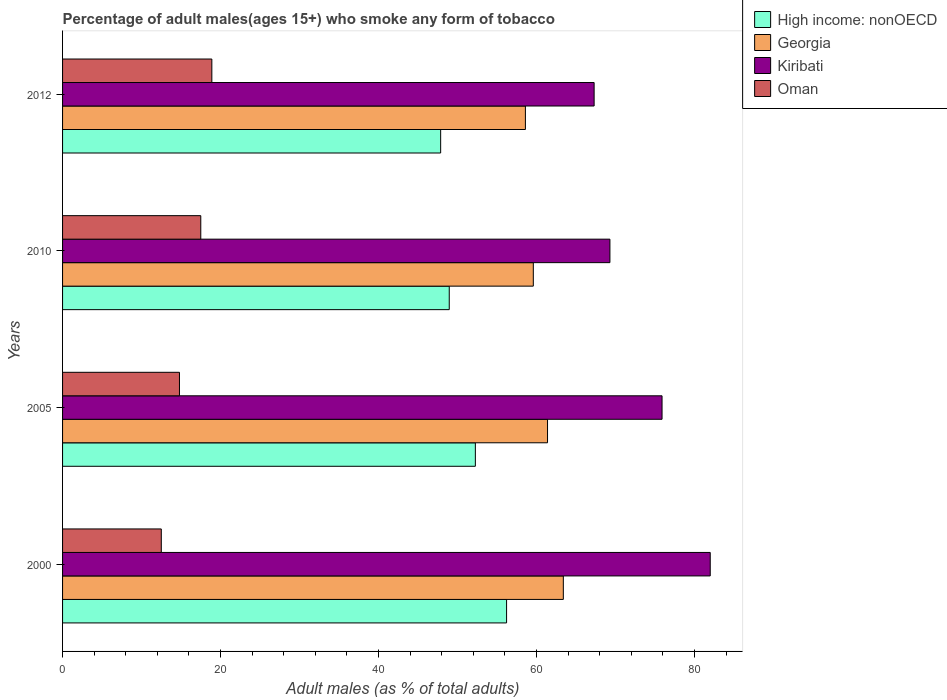How many different coloured bars are there?
Offer a very short reply. 4. How many groups of bars are there?
Keep it short and to the point. 4. Are the number of bars per tick equal to the number of legend labels?
Give a very brief answer. Yes. How many bars are there on the 3rd tick from the top?
Offer a very short reply. 4. What is the label of the 4th group of bars from the top?
Offer a very short reply. 2000. In how many cases, is the number of bars for a given year not equal to the number of legend labels?
Provide a succinct answer. 0. What is the percentage of adult males who smoke in Georgia in 2000?
Provide a short and direct response. 63.4. Across all years, what is the minimum percentage of adult males who smoke in Kiribati?
Keep it short and to the point. 67.3. In which year was the percentage of adult males who smoke in Kiribati maximum?
Give a very brief answer. 2000. In which year was the percentage of adult males who smoke in Oman minimum?
Offer a terse response. 2000. What is the total percentage of adult males who smoke in Kiribati in the graph?
Provide a succinct answer. 294.5. What is the difference between the percentage of adult males who smoke in High income: nonOECD in 2000 and that in 2012?
Keep it short and to the point. 8.35. What is the difference between the percentage of adult males who smoke in Oman in 2005 and the percentage of adult males who smoke in High income: nonOECD in 2000?
Keep it short and to the point. -41.42. What is the average percentage of adult males who smoke in High income: nonOECD per year?
Provide a short and direct response. 51.33. In the year 2012, what is the difference between the percentage of adult males who smoke in Oman and percentage of adult males who smoke in High income: nonOECD?
Provide a short and direct response. -28.97. In how many years, is the percentage of adult males who smoke in Georgia greater than 20 %?
Provide a short and direct response. 4. What is the ratio of the percentage of adult males who smoke in High income: nonOECD in 2000 to that in 2005?
Offer a very short reply. 1.08. Is the percentage of adult males who smoke in Georgia in 2000 less than that in 2010?
Ensure brevity in your answer.  No. Is the difference between the percentage of adult males who smoke in Oman in 2010 and 2012 greater than the difference between the percentage of adult males who smoke in High income: nonOECD in 2010 and 2012?
Your answer should be very brief. No. What is the difference between the highest and the second highest percentage of adult males who smoke in High income: nonOECD?
Offer a terse response. 3.95. What is the difference between the highest and the lowest percentage of adult males who smoke in High income: nonOECD?
Your response must be concise. 8.35. In how many years, is the percentage of adult males who smoke in Kiribati greater than the average percentage of adult males who smoke in Kiribati taken over all years?
Your response must be concise. 2. Is the sum of the percentage of adult males who smoke in Kiribati in 2010 and 2012 greater than the maximum percentage of adult males who smoke in Oman across all years?
Provide a short and direct response. Yes. What does the 1st bar from the top in 2000 represents?
Provide a short and direct response. Oman. What does the 1st bar from the bottom in 2000 represents?
Your response must be concise. High income: nonOECD. Is it the case that in every year, the sum of the percentage of adult males who smoke in Kiribati and percentage of adult males who smoke in High income: nonOECD is greater than the percentage of adult males who smoke in Georgia?
Make the answer very short. Yes. Are the values on the major ticks of X-axis written in scientific E-notation?
Keep it short and to the point. No. Does the graph contain any zero values?
Make the answer very short. No. Does the graph contain grids?
Your answer should be compact. No. How are the legend labels stacked?
Provide a succinct answer. Vertical. What is the title of the graph?
Provide a short and direct response. Percentage of adult males(ages 15+) who smoke any form of tobacco. What is the label or title of the X-axis?
Give a very brief answer. Adult males (as % of total adults). What is the label or title of the Y-axis?
Provide a succinct answer. Years. What is the Adult males (as % of total adults) of High income: nonOECD in 2000?
Your response must be concise. 56.22. What is the Adult males (as % of total adults) of Georgia in 2000?
Offer a terse response. 63.4. What is the Adult males (as % of total adults) in Kiribati in 2000?
Keep it short and to the point. 82. What is the Adult males (as % of total adults) in High income: nonOECD in 2005?
Provide a succinct answer. 52.26. What is the Adult males (as % of total adults) in Georgia in 2005?
Offer a very short reply. 61.4. What is the Adult males (as % of total adults) in Kiribati in 2005?
Provide a short and direct response. 75.9. What is the Adult males (as % of total adults) of High income: nonOECD in 2010?
Your answer should be very brief. 48.96. What is the Adult males (as % of total adults) of Georgia in 2010?
Your answer should be compact. 59.6. What is the Adult males (as % of total adults) of Kiribati in 2010?
Give a very brief answer. 69.3. What is the Adult males (as % of total adults) of High income: nonOECD in 2012?
Your answer should be compact. 47.87. What is the Adult males (as % of total adults) of Georgia in 2012?
Ensure brevity in your answer.  58.6. What is the Adult males (as % of total adults) of Kiribati in 2012?
Your response must be concise. 67.3. Across all years, what is the maximum Adult males (as % of total adults) in High income: nonOECD?
Make the answer very short. 56.22. Across all years, what is the maximum Adult males (as % of total adults) in Georgia?
Offer a very short reply. 63.4. Across all years, what is the minimum Adult males (as % of total adults) in High income: nonOECD?
Your answer should be very brief. 47.87. Across all years, what is the minimum Adult males (as % of total adults) of Georgia?
Give a very brief answer. 58.6. Across all years, what is the minimum Adult males (as % of total adults) in Kiribati?
Provide a short and direct response. 67.3. What is the total Adult males (as % of total adults) in High income: nonOECD in the graph?
Offer a terse response. 205.3. What is the total Adult males (as % of total adults) in Georgia in the graph?
Your response must be concise. 243. What is the total Adult males (as % of total adults) in Kiribati in the graph?
Your answer should be compact. 294.5. What is the total Adult males (as % of total adults) of Oman in the graph?
Offer a terse response. 63.7. What is the difference between the Adult males (as % of total adults) in High income: nonOECD in 2000 and that in 2005?
Your answer should be compact. 3.95. What is the difference between the Adult males (as % of total adults) of Kiribati in 2000 and that in 2005?
Make the answer very short. 6.1. What is the difference between the Adult males (as % of total adults) of Oman in 2000 and that in 2005?
Offer a very short reply. -2.3. What is the difference between the Adult males (as % of total adults) in High income: nonOECD in 2000 and that in 2010?
Offer a terse response. 7.26. What is the difference between the Adult males (as % of total adults) in Kiribati in 2000 and that in 2010?
Offer a terse response. 12.7. What is the difference between the Adult males (as % of total adults) in Oman in 2000 and that in 2010?
Provide a short and direct response. -5. What is the difference between the Adult males (as % of total adults) in High income: nonOECD in 2000 and that in 2012?
Ensure brevity in your answer.  8.35. What is the difference between the Adult males (as % of total adults) in Oman in 2000 and that in 2012?
Make the answer very short. -6.4. What is the difference between the Adult males (as % of total adults) of High income: nonOECD in 2005 and that in 2010?
Your answer should be compact. 3.31. What is the difference between the Adult males (as % of total adults) of Kiribati in 2005 and that in 2010?
Ensure brevity in your answer.  6.6. What is the difference between the Adult males (as % of total adults) in Oman in 2005 and that in 2010?
Your answer should be compact. -2.7. What is the difference between the Adult males (as % of total adults) of High income: nonOECD in 2005 and that in 2012?
Offer a terse response. 4.39. What is the difference between the Adult males (as % of total adults) in Georgia in 2005 and that in 2012?
Keep it short and to the point. 2.8. What is the difference between the Adult males (as % of total adults) of High income: nonOECD in 2010 and that in 2012?
Offer a very short reply. 1.09. What is the difference between the Adult males (as % of total adults) of Georgia in 2010 and that in 2012?
Offer a terse response. 1. What is the difference between the Adult males (as % of total adults) of Kiribati in 2010 and that in 2012?
Your answer should be compact. 2. What is the difference between the Adult males (as % of total adults) of High income: nonOECD in 2000 and the Adult males (as % of total adults) of Georgia in 2005?
Your response must be concise. -5.18. What is the difference between the Adult males (as % of total adults) in High income: nonOECD in 2000 and the Adult males (as % of total adults) in Kiribati in 2005?
Provide a short and direct response. -19.68. What is the difference between the Adult males (as % of total adults) in High income: nonOECD in 2000 and the Adult males (as % of total adults) in Oman in 2005?
Offer a very short reply. 41.42. What is the difference between the Adult males (as % of total adults) of Georgia in 2000 and the Adult males (as % of total adults) of Oman in 2005?
Offer a terse response. 48.6. What is the difference between the Adult males (as % of total adults) of Kiribati in 2000 and the Adult males (as % of total adults) of Oman in 2005?
Keep it short and to the point. 67.2. What is the difference between the Adult males (as % of total adults) of High income: nonOECD in 2000 and the Adult males (as % of total adults) of Georgia in 2010?
Your response must be concise. -3.38. What is the difference between the Adult males (as % of total adults) in High income: nonOECD in 2000 and the Adult males (as % of total adults) in Kiribati in 2010?
Your response must be concise. -13.08. What is the difference between the Adult males (as % of total adults) of High income: nonOECD in 2000 and the Adult males (as % of total adults) of Oman in 2010?
Offer a terse response. 38.72. What is the difference between the Adult males (as % of total adults) in Georgia in 2000 and the Adult males (as % of total adults) in Oman in 2010?
Provide a succinct answer. 45.9. What is the difference between the Adult males (as % of total adults) in Kiribati in 2000 and the Adult males (as % of total adults) in Oman in 2010?
Ensure brevity in your answer.  64.5. What is the difference between the Adult males (as % of total adults) in High income: nonOECD in 2000 and the Adult males (as % of total adults) in Georgia in 2012?
Offer a terse response. -2.38. What is the difference between the Adult males (as % of total adults) of High income: nonOECD in 2000 and the Adult males (as % of total adults) of Kiribati in 2012?
Your answer should be compact. -11.08. What is the difference between the Adult males (as % of total adults) of High income: nonOECD in 2000 and the Adult males (as % of total adults) of Oman in 2012?
Your answer should be very brief. 37.32. What is the difference between the Adult males (as % of total adults) of Georgia in 2000 and the Adult males (as % of total adults) of Kiribati in 2012?
Provide a short and direct response. -3.9. What is the difference between the Adult males (as % of total adults) of Georgia in 2000 and the Adult males (as % of total adults) of Oman in 2012?
Make the answer very short. 44.5. What is the difference between the Adult males (as % of total adults) in Kiribati in 2000 and the Adult males (as % of total adults) in Oman in 2012?
Offer a very short reply. 63.1. What is the difference between the Adult males (as % of total adults) in High income: nonOECD in 2005 and the Adult males (as % of total adults) in Georgia in 2010?
Offer a terse response. -7.34. What is the difference between the Adult males (as % of total adults) in High income: nonOECD in 2005 and the Adult males (as % of total adults) in Kiribati in 2010?
Give a very brief answer. -17.04. What is the difference between the Adult males (as % of total adults) in High income: nonOECD in 2005 and the Adult males (as % of total adults) in Oman in 2010?
Your response must be concise. 34.76. What is the difference between the Adult males (as % of total adults) in Georgia in 2005 and the Adult males (as % of total adults) in Kiribati in 2010?
Give a very brief answer. -7.9. What is the difference between the Adult males (as % of total adults) of Georgia in 2005 and the Adult males (as % of total adults) of Oman in 2010?
Your response must be concise. 43.9. What is the difference between the Adult males (as % of total adults) of Kiribati in 2005 and the Adult males (as % of total adults) of Oman in 2010?
Your answer should be compact. 58.4. What is the difference between the Adult males (as % of total adults) in High income: nonOECD in 2005 and the Adult males (as % of total adults) in Georgia in 2012?
Your answer should be very brief. -6.34. What is the difference between the Adult males (as % of total adults) of High income: nonOECD in 2005 and the Adult males (as % of total adults) of Kiribati in 2012?
Your answer should be very brief. -15.04. What is the difference between the Adult males (as % of total adults) in High income: nonOECD in 2005 and the Adult males (as % of total adults) in Oman in 2012?
Your answer should be compact. 33.36. What is the difference between the Adult males (as % of total adults) of Georgia in 2005 and the Adult males (as % of total adults) of Kiribati in 2012?
Offer a terse response. -5.9. What is the difference between the Adult males (as % of total adults) in Georgia in 2005 and the Adult males (as % of total adults) in Oman in 2012?
Ensure brevity in your answer.  42.5. What is the difference between the Adult males (as % of total adults) in Kiribati in 2005 and the Adult males (as % of total adults) in Oman in 2012?
Offer a very short reply. 57. What is the difference between the Adult males (as % of total adults) of High income: nonOECD in 2010 and the Adult males (as % of total adults) of Georgia in 2012?
Offer a very short reply. -9.64. What is the difference between the Adult males (as % of total adults) of High income: nonOECD in 2010 and the Adult males (as % of total adults) of Kiribati in 2012?
Make the answer very short. -18.34. What is the difference between the Adult males (as % of total adults) of High income: nonOECD in 2010 and the Adult males (as % of total adults) of Oman in 2012?
Keep it short and to the point. 30.06. What is the difference between the Adult males (as % of total adults) of Georgia in 2010 and the Adult males (as % of total adults) of Oman in 2012?
Ensure brevity in your answer.  40.7. What is the difference between the Adult males (as % of total adults) of Kiribati in 2010 and the Adult males (as % of total adults) of Oman in 2012?
Give a very brief answer. 50.4. What is the average Adult males (as % of total adults) of High income: nonOECD per year?
Make the answer very short. 51.33. What is the average Adult males (as % of total adults) of Georgia per year?
Your answer should be compact. 60.75. What is the average Adult males (as % of total adults) of Kiribati per year?
Offer a very short reply. 73.62. What is the average Adult males (as % of total adults) of Oman per year?
Provide a short and direct response. 15.93. In the year 2000, what is the difference between the Adult males (as % of total adults) of High income: nonOECD and Adult males (as % of total adults) of Georgia?
Your answer should be very brief. -7.18. In the year 2000, what is the difference between the Adult males (as % of total adults) in High income: nonOECD and Adult males (as % of total adults) in Kiribati?
Offer a very short reply. -25.78. In the year 2000, what is the difference between the Adult males (as % of total adults) in High income: nonOECD and Adult males (as % of total adults) in Oman?
Offer a very short reply. 43.72. In the year 2000, what is the difference between the Adult males (as % of total adults) of Georgia and Adult males (as % of total adults) of Kiribati?
Keep it short and to the point. -18.6. In the year 2000, what is the difference between the Adult males (as % of total adults) of Georgia and Adult males (as % of total adults) of Oman?
Ensure brevity in your answer.  50.9. In the year 2000, what is the difference between the Adult males (as % of total adults) in Kiribati and Adult males (as % of total adults) in Oman?
Provide a succinct answer. 69.5. In the year 2005, what is the difference between the Adult males (as % of total adults) in High income: nonOECD and Adult males (as % of total adults) in Georgia?
Provide a short and direct response. -9.14. In the year 2005, what is the difference between the Adult males (as % of total adults) of High income: nonOECD and Adult males (as % of total adults) of Kiribati?
Offer a terse response. -23.64. In the year 2005, what is the difference between the Adult males (as % of total adults) in High income: nonOECD and Adult males (as % of total adults) in Oman?
Ensure brevity in your answer.  37.46. In the year 2005, what is the difference between the Adult males (as % of total adults) in Georgia and Adult males (as % of total adults) in Oman?
Offer a very short reply. 46.6. In the year 2005, what is the difference between the Adult males (as % of total adults) of Kiribati and Adult males (as % of total adults) of Oman?
Give a very brief answer. 61.1. In the year 2010, what is the difference between the Adult males (as % of total adults) in High income: nonOECD and Adult males (as % of total adults) in Georgia?
Provide a short and direct response. -10.64. In the year 2010, what is the difference between the Adult males (as % of total adults) of High income: nonOECD and Adult males (as % of total adults) of Kiribati?
Offer a terse response. -20.34. In the year 2010, what is the difference between the Adult males (as % of total adults) in High income: nonOECD and Adult males (as % of total adults) in Oman?
Make the answer very short. 31.46. In the year 2010, what is the difference between the Adult males (as % of total adults) in Georgia and Adult males (as % of total adults) in Oman?
Offer a very short reply. 42.1. In the year 2010, what is the difference between the Adult males (as % of total adults) in Kiribati and Adult males (as % of total adults) in Oman?
Your answer should be compact. 51.8. In the year 2012, what is the difference between the Adult males (as % of total adults) of High income: nonOECD and Adult males (as % of total adults) of Georgia?
Your answer should be very brief. -10.73. In the year 2012, what is the difference between the Adult males (as % of total adults) in High income: nonOECD and Adult males (as % of total adults) in Kiribati?
Ensure brevity in your answer.  -19.43. In the year 2012, what is the difference between the Adult males (as % of total adults) of High income: nonOECD and Adult males (as % of total adults) of Oman?
Ensure brevity in your answer.  28.97. In the year 2012, what is the difference between the Adult males (as % of total adults) in Georgia and Adult males (as % of total adults) in Kiribati?
Provide a succinct answer. -8.7. In the year 2012, what is the difference between the Adult males (as % of total adults) of Georgia and Adult males (as % of total adults) of Oman?
Your answer should be very brief. 39.7. In the year 2012, what is the difference between the Adult males (as % of total adults) in Kiribati and Adult males (as % of total adults) in Oman?
Your answer should be compact. 48.4. What is the ratio of the Adult males (as % of total adults) of High income: nonOECD in 2000 to that in 2005?
Provide a succinct answer. 1.08. What is the ratio of the Adult males (as % of total adults) in Georgia in 2000 to that in 2005?
Provide a succinct answer. 1.03. What is the ratio of the Adult males (as % of total adults) of Kiribati in 2000 to that in 2005?
Give a very brief answer. 1.08. What is the ratio of the Adult males (as % of total adults) of Oman in 2000 to that in 2005?
Make the answer very short. 0.84. What is the ratio of the Adult males (as % of total adults) of High income: nonOECD in 2000 to that in 2010?
Provide a short and direct response. 1.15. What is the ratio of the Adult males (as % of total adults) of Georgia in 2000 to that in 2010?
Your response must be concise. 1.06. What is the ratio of the Adult males (as % of total adults) of Kiribati in 2000 to that in 2010?
Make the answer very short. 1.18. What is the ratio of the Adult males (as % of total adults) in High income: nonOECD in 2000 to that in 2012?
Ensure brevity in your answer.  1.17. What is the ratio of the Adult males (as % of total adults) in Georgia in 2000 to that in 2012?
Your answer should be very brief. 1.08. What is the ratio of the Adult males (as % of total adults) in Kiribati in 2000 to that in 2012?
Provide a succinct answer. 1.22. What is the ratio of the Adult males (as % of total adults) in Oman in 2000 to that in 2012?
Your response must be concise. 0.66. What is the ratio of the Adult males (as % of total adults) of High income: nonOECD in 2005 to that in 2010?
Keep it short and to the point. 1.07. What is the ratio of the Adult males (as % of total adults) in Georgia in 2005 to that in 2010?
Your response must be concise. 1.03. What is the ratio of the Adult males (as % of total adults) in Kiribati in 2005 to that in 2010?
Make the answer very short. 1.1. What is the ratio of the Adult males (as % of total adults) of Oman in 2005 to that in 2010?
Ensure brevity in your answer.  0.85. What is the ratio of the Adult males (as % of total adults) in High income: nonOECD in 2005 to that in 2012?
Provide a succinct answer. 1.09. What is the ratio of the Adult males (as % of total adults) in Georgia in 2005 to that in 2012?
Provide a short and direct response. 1.05. What is the ratio of the Adult males (as % of total adults) in Kiribati in 2005 to that in 2012?
Ensure brevity in your answer.  1.13. What is the ratio of the Adult males (as % of total adults) of Oman in 2005 to that in 2012?
Make the answer very short. 0.78. What is the ratio of the Adult males (as % of total adults) in High income: nonOECD in 2010 to that in 2012?
Keep it short and to the point. 1.02. What is the ratio of the Adult males (as % of total adults) in Georgia in 2010 to that in 2012?
Ensure brevity in your answer.  1.02. What is the ratio of the Adult males (as % of total adults) in Kiribati in 2010 to that in 2012?
Offer a very short reply. 1.03. What is the ratio of the Adult males (as % of total adults) of Oman in 2010 to that in 2012?
Offer a terse response. 0.93. What is the difference between the highest and the second highest Adult males (as % of total adults) of High income: nonOECD?
Provide a short and direct response. 3.95. What is the difference between the highest and the second highest Adult males (as % of total adults) in Kiribati?
Your answer should be very brief. 6.1. What is the difference between the highest and the lowest Adult males (as % of total adults) in High income: nonOECD?
Your answer should be very brief. 8.35. What is the difference between the highest and the lowest Adult males (as % of total adults) in Georgia?
Ensure brevity in your answer.  4.8. What is the difference between the highest and the lowest Adult males (as % of total adults) in Kiribati?
Provide a short and direct response. 14.7. What is the difference between the highest and the lowest Adult males (as % of total adults) in Oman?
Provide a short and direct response. 6.4. 